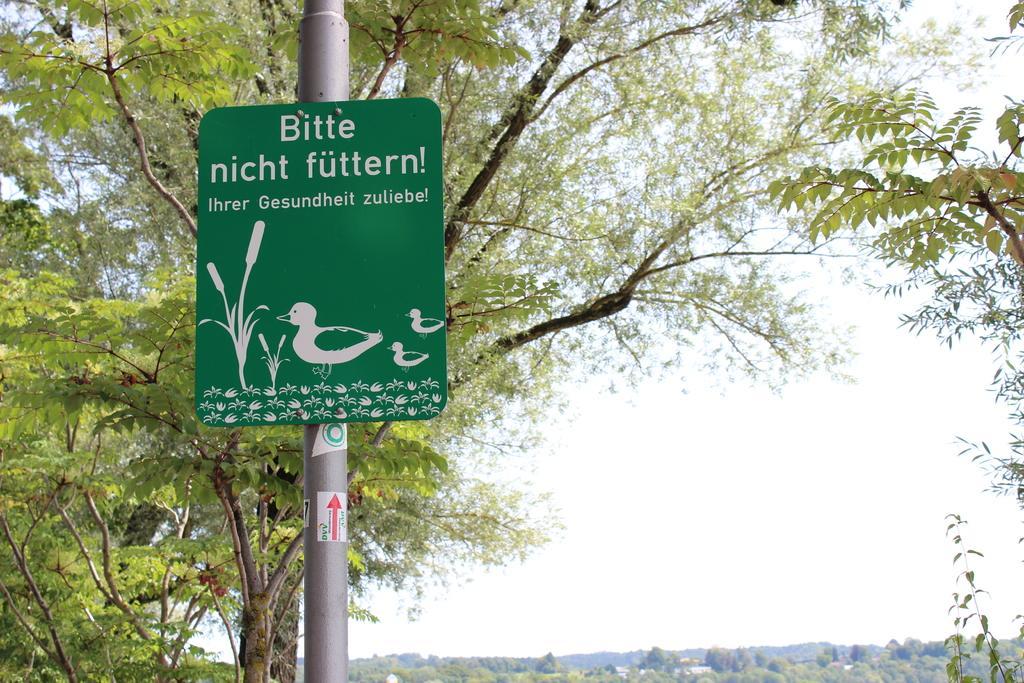Describe this image in one or two sentences. In this picture we can observe a green color board fixed to the pole. We can observe text on the board. We can observe trees. In the background there is a sky. 